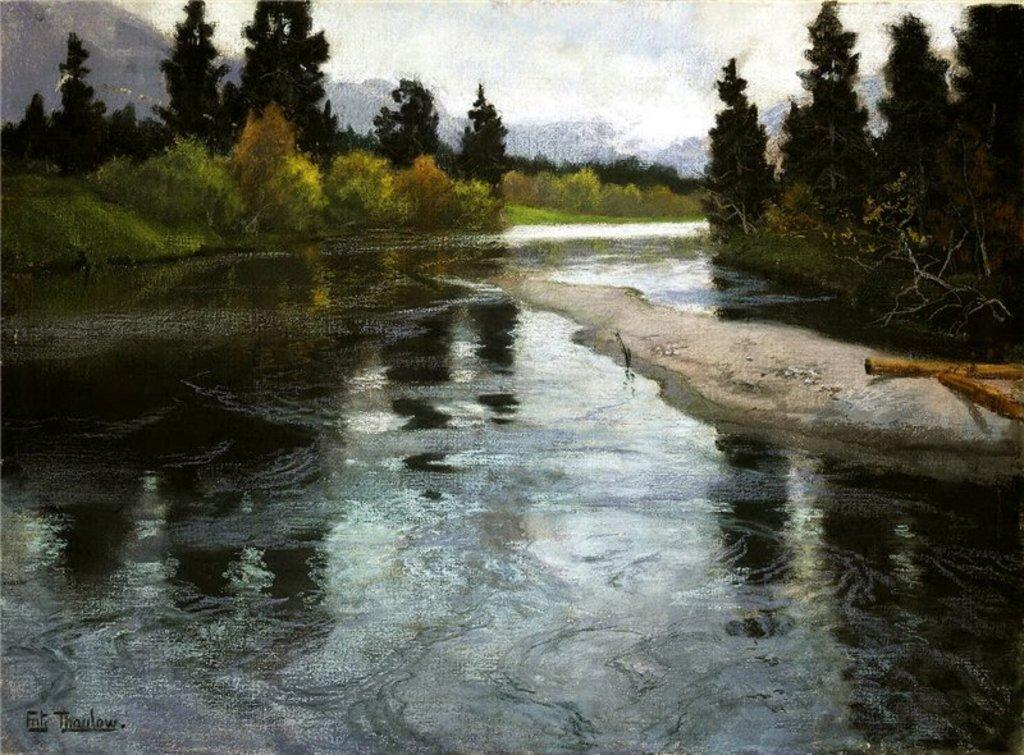What is the primary element visible element in the image? There is water in the image. What type of vegetation is present on either side of the water? There are trees on either side of the water. What can be seen in the distance in the image? There are mountains in the background of the image. How many potatoes are visible in the image? There are no potatoes present in the image. What type of basket can be seen in the image? There is no basket present in the image. 